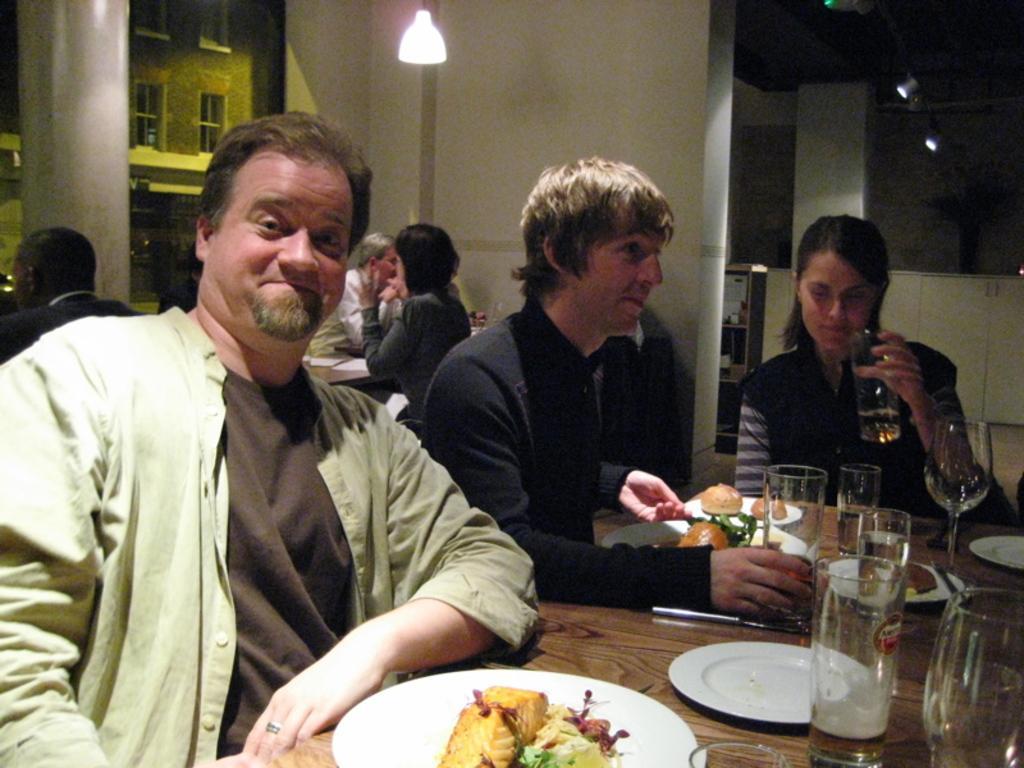How would you summarize this image in a sentence or two? on a wooden table there are glasses,plates and food items in the plates. the person at the left is wearing green shirt. next to him a person is wearing black t shirt. the person at the right is wearing a black t shirt and holding a glass in her hand. at the left there are people sitting. behind them there is a white pillar and a building at its back. at the back there is a white wall and a light on the top. 